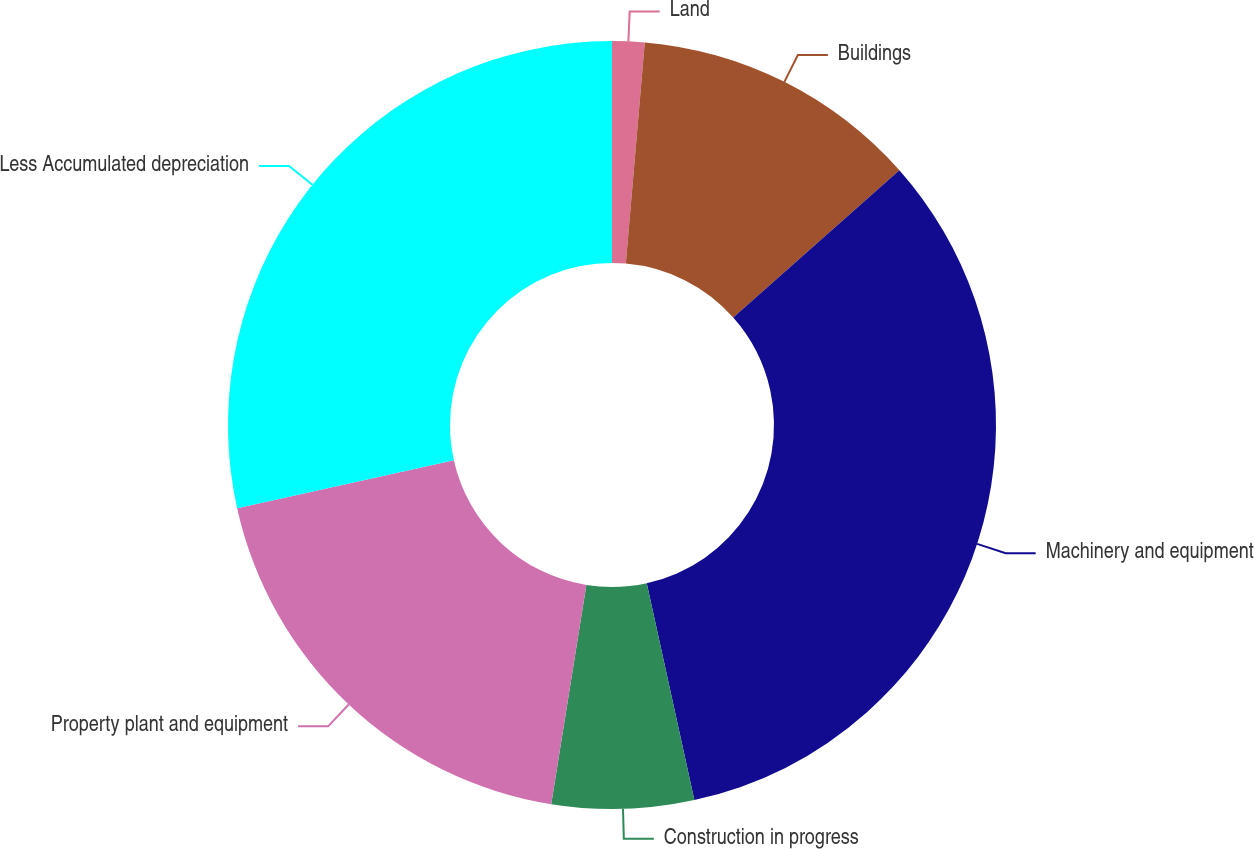Convert chart to OTSL. <chart><loc_0><loc_0><loc_500><loc_500><pie_chart><fcel>Land<fcel>Buildings<fcel>Machinery and equipment<fcel>Construction in progress<fcel>Property plant and equipment<fcel>Less Accumulated depreciation<nl><fcel>1.36%<fcel>12.1%<fcel>33.1%<fcel>5.97%<fcel>18.99%<fcel>28.48%<nl></chart> 